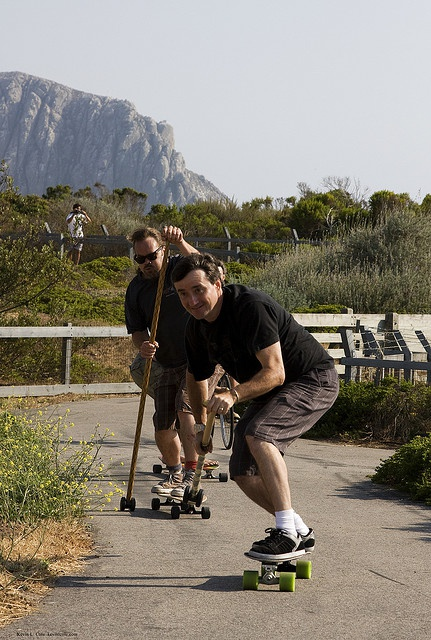Describe the objects in this image and their specific colors. I can see people in lightgray, black, gray, and maroon tones, people in lightgray, black, maroon, and gray tones, skateboard in lightgray, black, darkgreen, and gray tones, skateboard in lightgray, black, gray, and darkgray tones, and people in lightgray, black, gray, and darkgray tones in this image. 